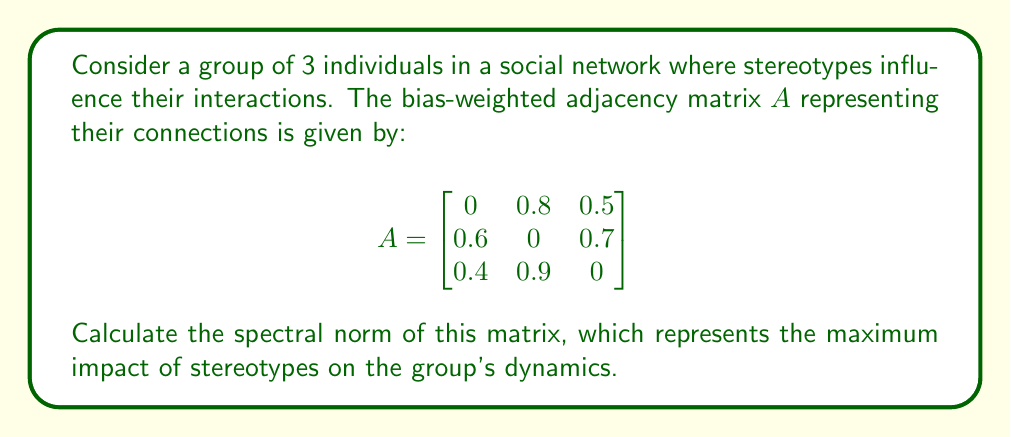Can you solve this math problem? To find the spectral norm of the bias-weighted adjacency matrix $A$, we follow these steps:

1) The spectral norm is defined as the square root of the largest eigenvalue of $A^TA$, where $A^T$ is the transpose of $A$.

2) First, we calculate $A^TA$:

   $$A^TA = \begin{bmatrix}
   0 & 0.6 & 0.4 \\
   0.8 & 0 & 0.9 \\
   0.5 & 0.7 & 0
   \end{bmatrix} \times 
   \begin{bmatrix}
   0 & 0.8 & 0.5 \\
   0.6 & 0 & 0.7 \\
   0.4 & 0.9 & 0
   \end{bmatrix}$$

   $$= \begin{bmatrix}
   0.52 & 0.54 & 0.42 \\
   0.54 & 1.45 & 0.40 \\
   0.42 & 0.40 & 0.74
   \end{bmatrix}$$

3) Now, we need to find the eigenvalues of $A^TA$. The characteristic equation is:

   $$det(A^TA - \lambda I) = 0$$

   $$(0.52 - \lambda)(1.45 - \lambda)(0.74 - \lambda) - 0.54^2(0.74 - \lambda) - 0.42^2(1.45 - \lambda) - 0.40^2(0.52 - \lambda) + 2(0.54)(0.42)(0.40) = 0$$

4) Solving this equation (which can be done using numerical methods) gives us the eigenvalues:

   $\lambda_1 \approx 1.8559$
   $\lambda_2 \approx 0.6841$
   $\lambda_3 \approx 0.1600$

5) The largest eigenvalue is $\lambda_1 \approx 1.8559$.

6) The spectral norm is the square root of this largest eigenvalue:

   $$\|A\|_2 = \sqrt{\lambda_1} \approx \sqrt{1.8559} \approx 1.3623$$

This value represents the maximum impact of stereotypes on the group's dynamics in this social network.
Answer: $1.3623$ 